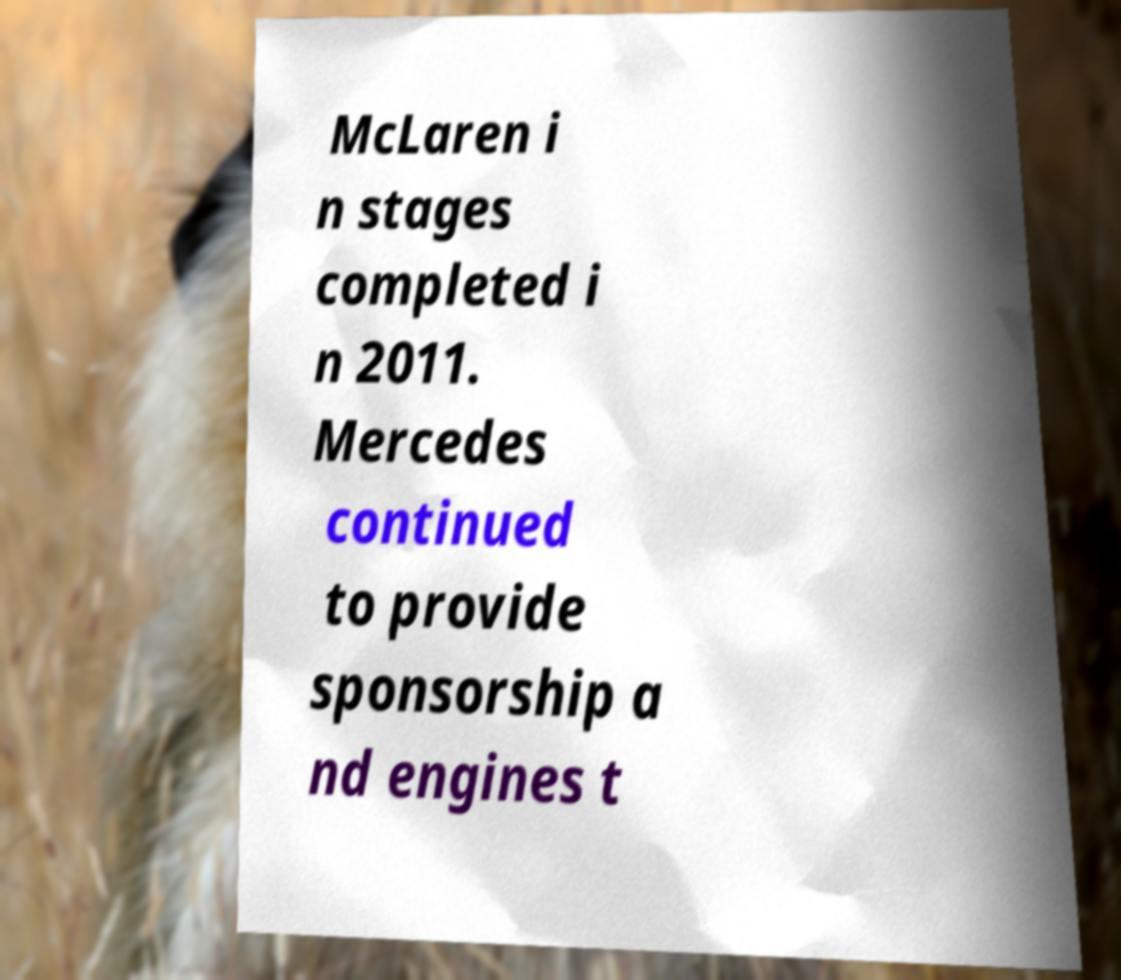Could you assist in decoding the text presented in this image and type it out clearly? McLaren i n stages completed i n 2011. Mercedes continued to provide sponsorship a nd engines t 